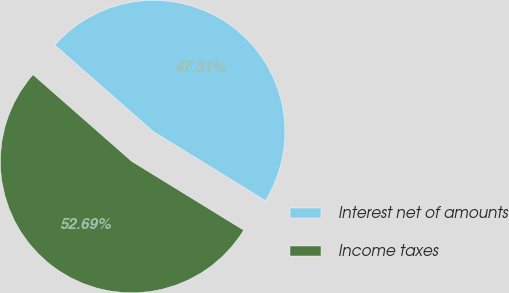Convert chart to OTSL. <chart><loc_0><loc_0><loc_500><loc_500><pie_chart><fcel>Interest net of amounts<fcel>Income taxes<nl><fcel>47.31%<fcel>52.69%<nl></chart> 